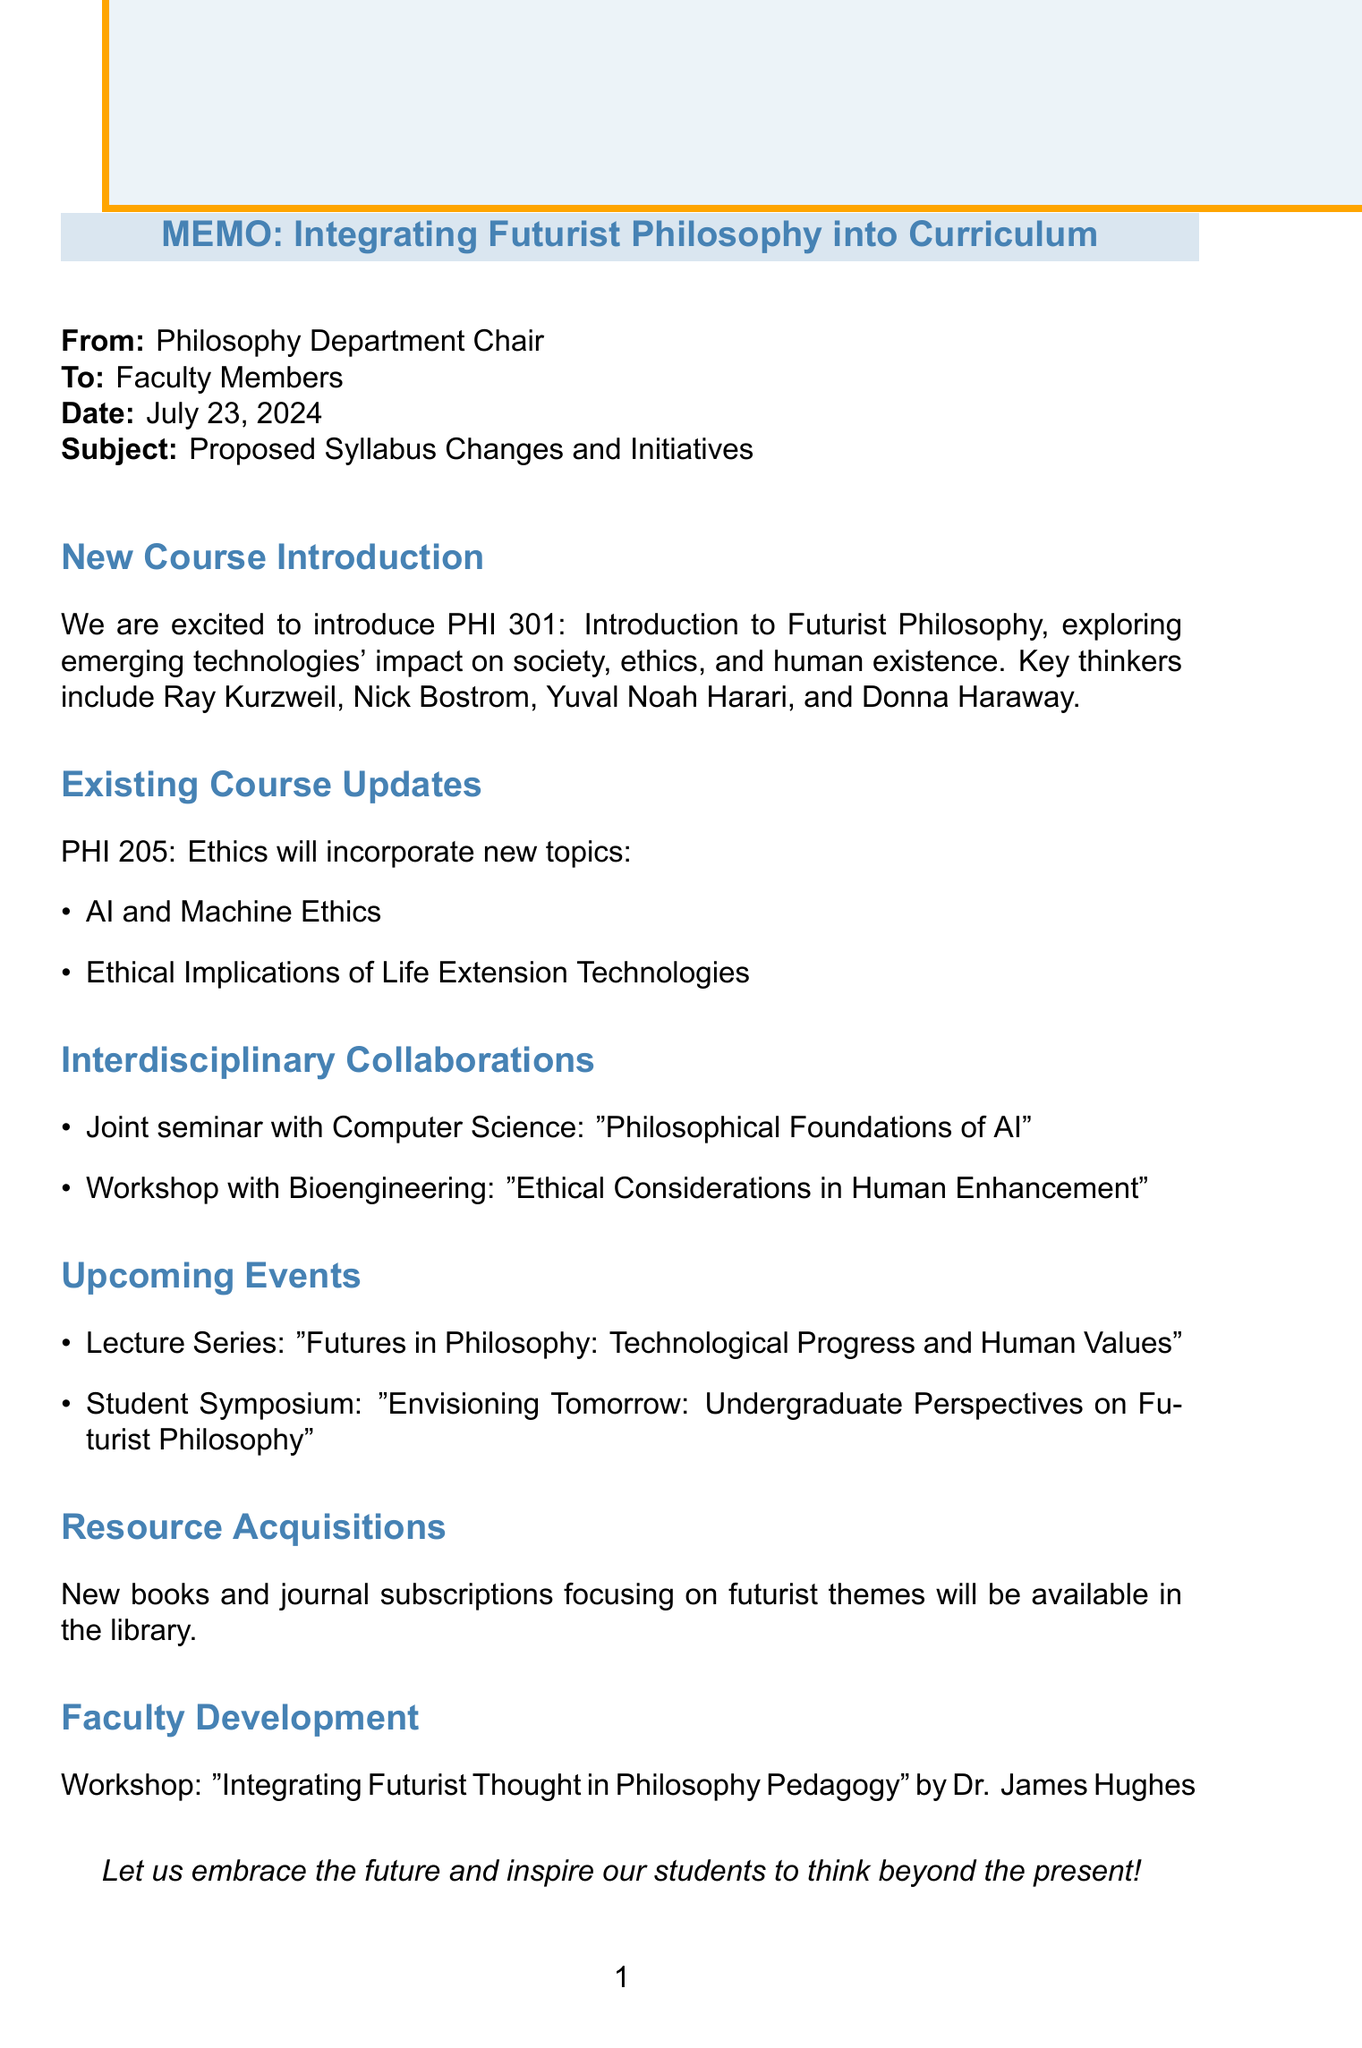What is the new course being introduced? The document states the introduction of PHI 301, focusing on futurist philosophy and emerging technologies.
Answer: PHI 301: Introduction to Futurist Philosophy Who is a key thinker mentioned in the new course? The document lists several thinkers, including Ray Kurzweil, as key figures in futurist philosophy.
Answer: Ray Kurzweil What is one of the main topics of the new course? The main topics listed include Transhumanism, which is one of the areas covered in the new course.
Answer: Transhumanism Which existing course will be updated? The document mentions updates to an existing course, specifically PHI 205.
Answer: PHI 205: Ethics What is the name of the joint seminar with the Computer Science department? The document specifies the seminar's title as "Philosophical Foundations of Artificial Intelligence."
Answer: Philosophical Foundations of Artificial Intelligence Name one of the speakers in the upcoming lecture series. The document lists multiple speakers, including Dr. David Chalmers, who will be part of the lecture series.
Answer: Dr. David Chalmers What is the facilitator's name for the faculty development workshop? The document provides the facilitator's name as Dr. James Hughes for the workshop on futurist thought.
Answer: Dr. James Hughes What type of event is "Envisioning Tomorrow"? The document describes this as a student symposium focusing on undergraduate perspectives on futurist philosophy.
Answer: Student Symposium Which book is mentioned for resource acquisition? The document lists several titles for resource acquisition, among them "Homo Deus: A Brief History of Tomorrow."
Answer: Homo Deus: A Brief History of Tomorrow 